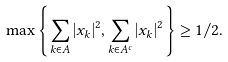<formula> <loc_0><loc_0><loc_500><loc_500>\max \left \{ \sum _ { k \in A } | x _ { k } | ^ { 2 } , \sum _ { k \in A ^ { c } } | x _ { k } | ^ { 2 } \right \} \geq 1 / 2 .</formula> 